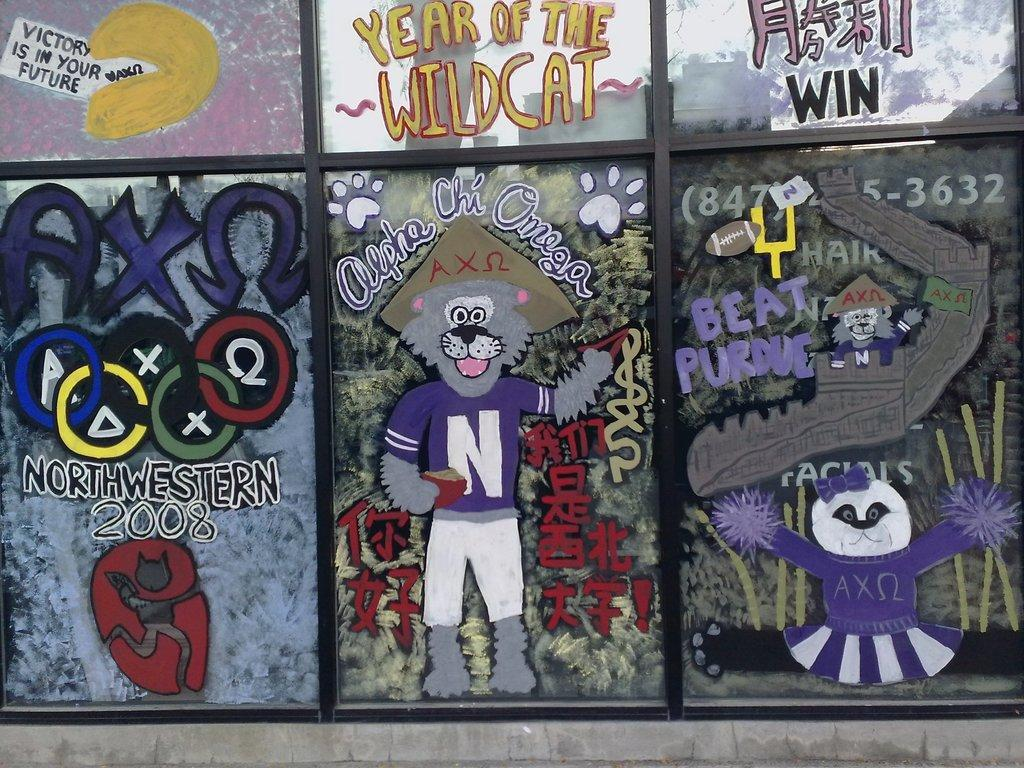What type of material is used for the windows in the image? There are glass windows in the image. What is depicted on the glass windows? There are cartoon pictures on the glass windows. Is there any text on the glass windows? Yes, there is writing on the glass windows. How many colors are used for the writing on the glass windows? The writing on the glass windows is in multiple colors. What is the tendency of the friend to join the group in the image? There is no friend or group present in the image, so it is not possible to determine any tendencies. 